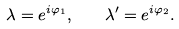<formula> <loc_0><loc_0><loc_500><loc_500>\lambda = e ^ { i \varphi _ { 1 } } , \quad \lambda ^ { \prime } = e ^ { i \varphi _ { 2 } } .</formula> 